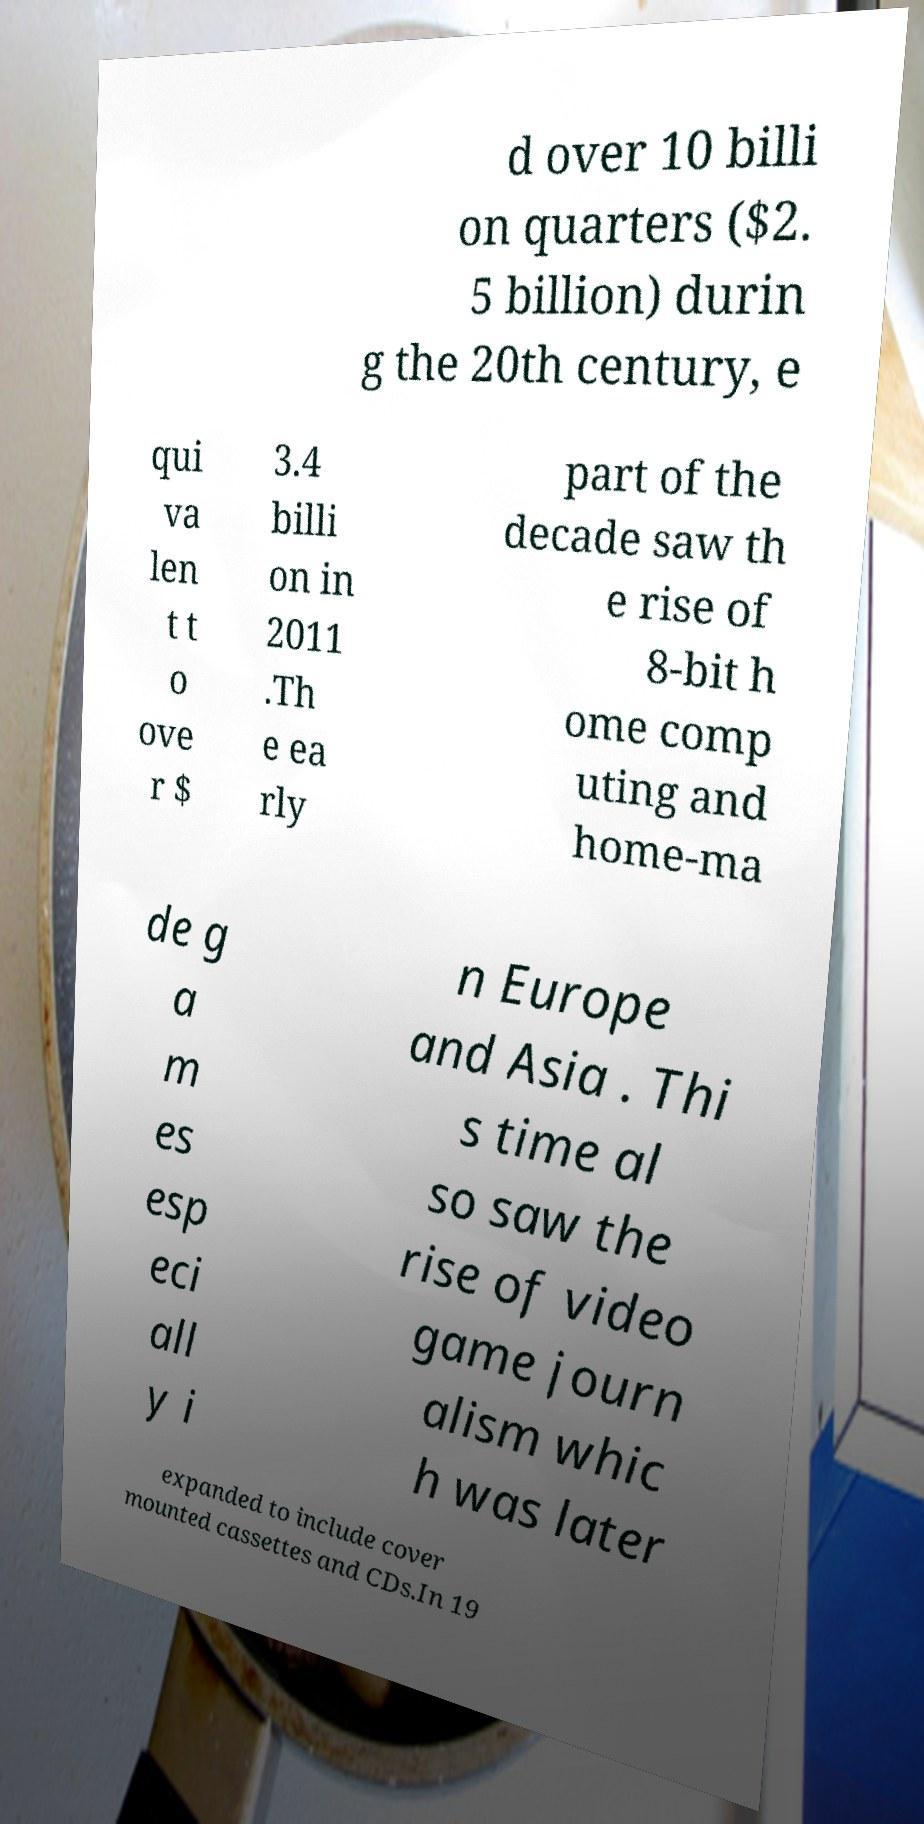Can you read and provide the text displayed in the image?This photo seems to have some interesting text. Can you extract and type it out for me? d over 10 billi on quarters ($2. 5 billion) durin g the 20th century, e qui va len t t o ove r $ 3.4 billi on in 2011 .Th e ea rly part of the decade saw th e rise of 8-bit h ome comp uting and home-ma de g a m es esp eci all y i n Europe and Asia . Thi s time al so saw the rise of video game journ alism whic h was later expanded to include cover mounted cassettes and CDs.In 19 